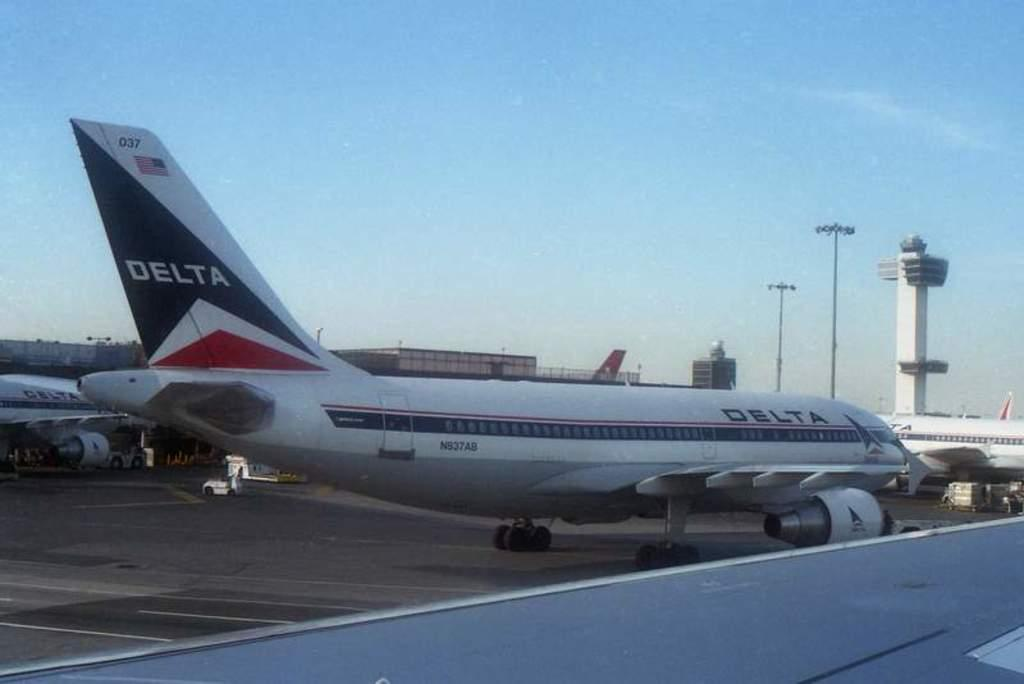What is the main subject of the image? The main subject of the image is an aeroplane. What colors are used for the aeroplane? The aeroplane is in white and blue colors. Where might this image have been taken? The image appears to be at an airport. What is visible at the top of the image? The sky is visible at the top of the image. What can be seen on the right side of the image? There are lights on the right side of the image. What type of ice can be seen melting on the aeroplane's wing in the image? There is no ice visible on the aeroplane's wing in the image. How many sticks are used to hold the offer in the image? There is no offer or sticks present in the image. 